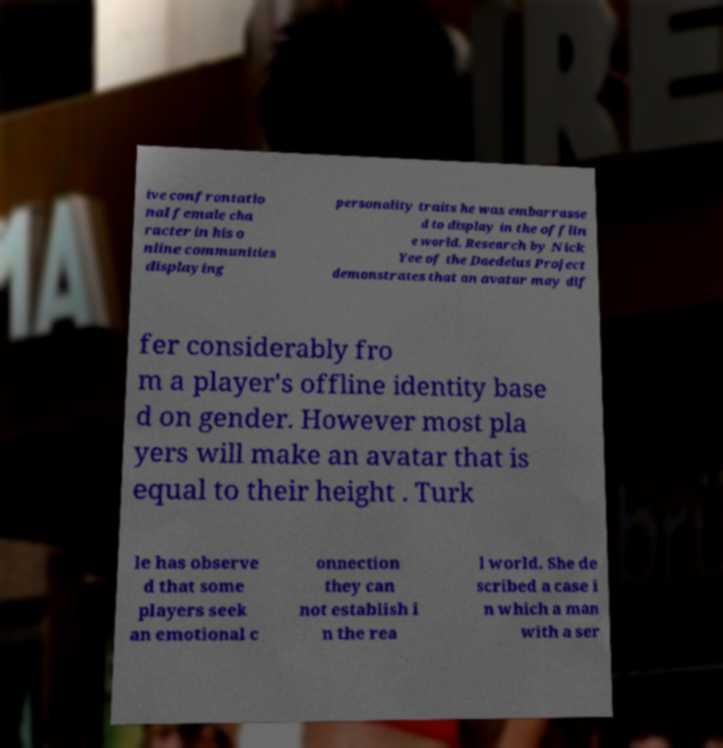Could you extract and type out the text from this image? ive confrontatio nal female cha racter in his o nline communities displaying personality traits he was embarrasse d to display in the offlin e world. Research by Nick Yee of the Daedelus Project demonstrates that an avatar may dif fer considerably fro m a player's offline identity base d on gender. However most pla yers will make an avatar that is equal to their height . Turk le has observe d that some players seek an emotional c onnection they can not establish i n the rea l world. She de scribed a case i n which a man with a ser 